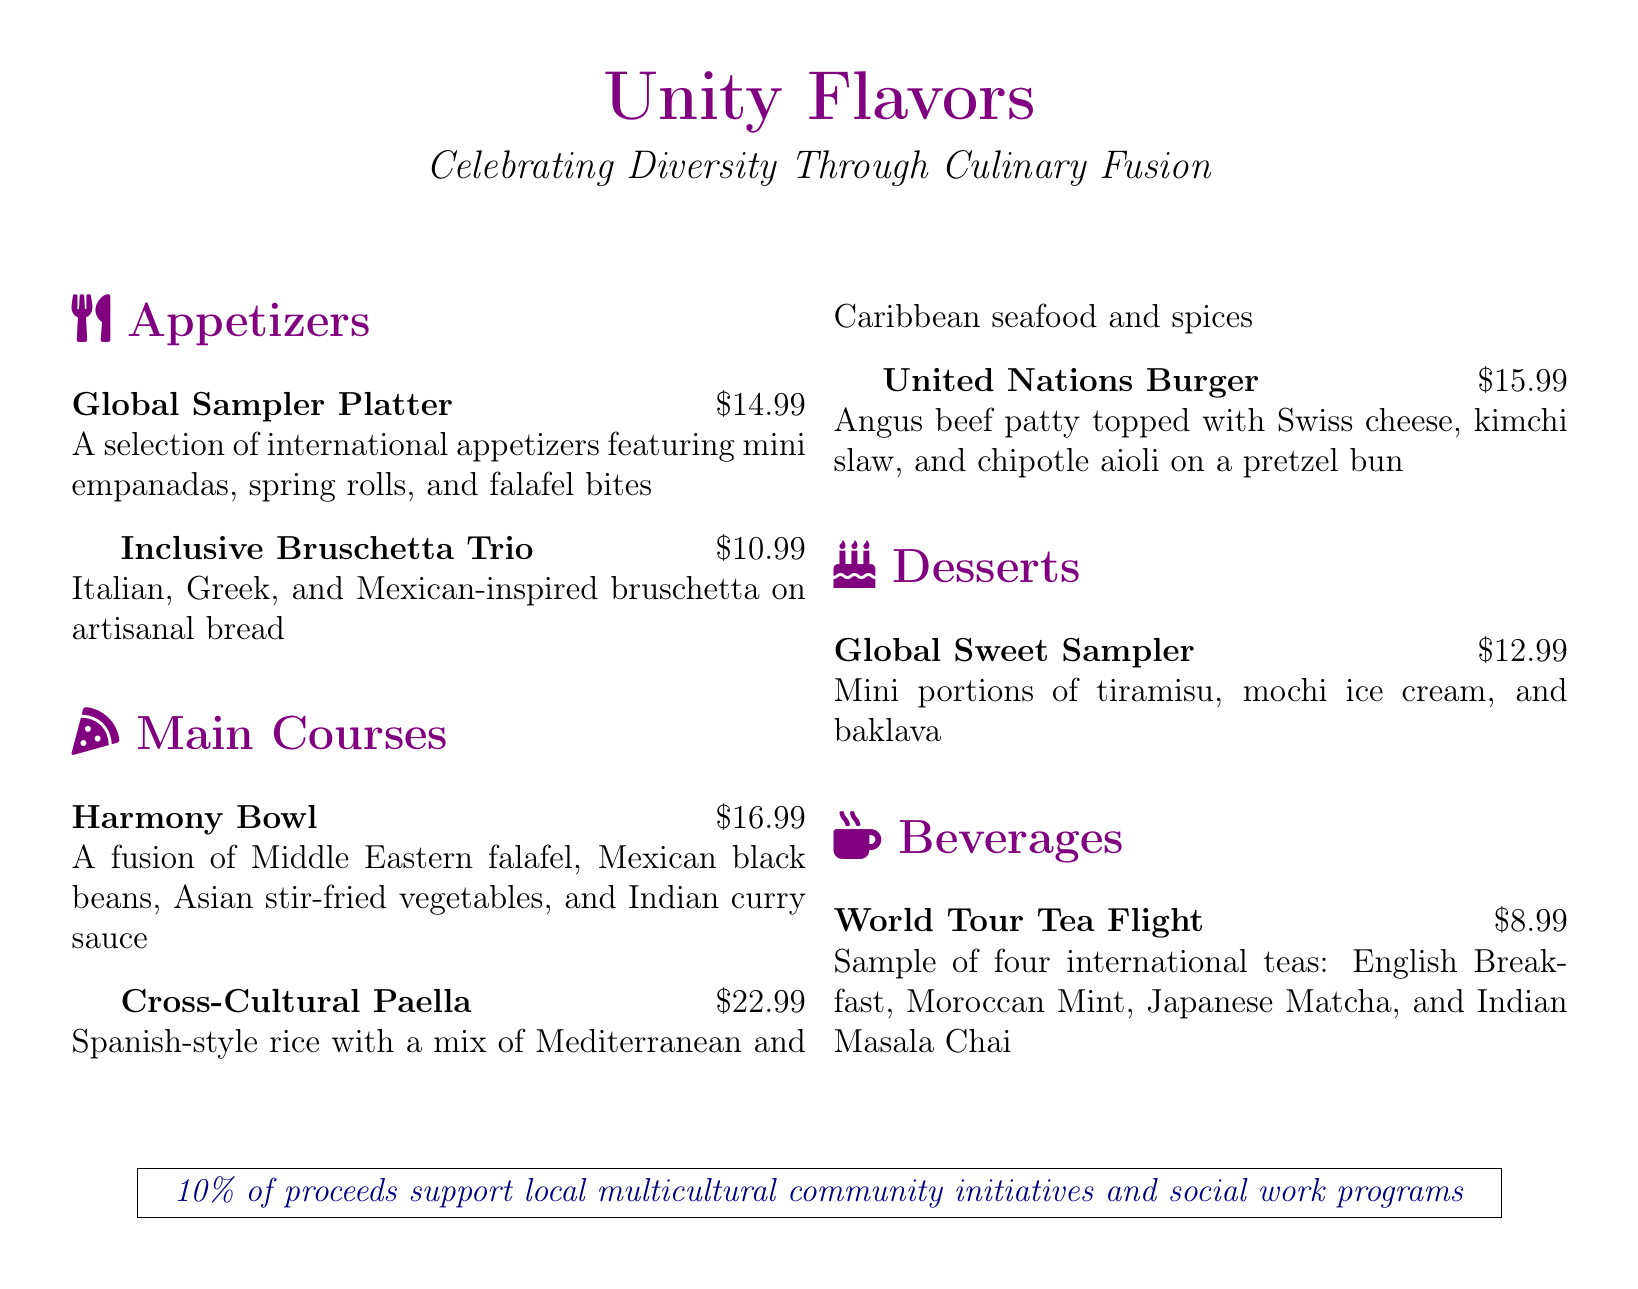What is the name of the restaurant? The name of the restaurant is prominently displayed at the top of the menu.
Answer: Unity Flavors What appetizer features mini empanadas? The appetizer section includes a selection of items, and mini empanadas are part of a specific dish.
Answer: Global Sampler Platter How much does the Inclusive Bruschetta Trio cost? The price of this specific appetizer is listed next to its description.
Answer: $10.99 What is included in the World Tour Tea Flight? The tea flight features a selection of international teas mentioned in the beverage section.
Answer: English Breakfast, Moroccan Mint, Japanese Matcha, Indian Masala Chai What type of burger is offered? The menu describes a unique burger that combines styles from different cultures.
Answer: United Nations Burger What is the price of the Global Sweet Sampler? The price for this dessert option is stated clearly in the menu.
Answer: $12.99 Which dish represents a fusion of Middle Eastern and Mexican cuisines? The dish combines elements from these regions, as described in the main courses.
Answer: Harmony Bowl How much percentage of proceeds goes to community initiatives? The text at the bottom of the menu states the percentage of proceeds directed to charitable causes.
Answer: 10% 